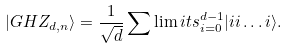<formula> <loc_0><loc_0><loc_500><loc_500>| G H Z _ { d , n } \rangle = \frac { 1 } { \sqrt { d } } \sum \lim i t s _ { i = 0 } ^ { d - 1 } { | i i \dots i \rangle } .</formula> 